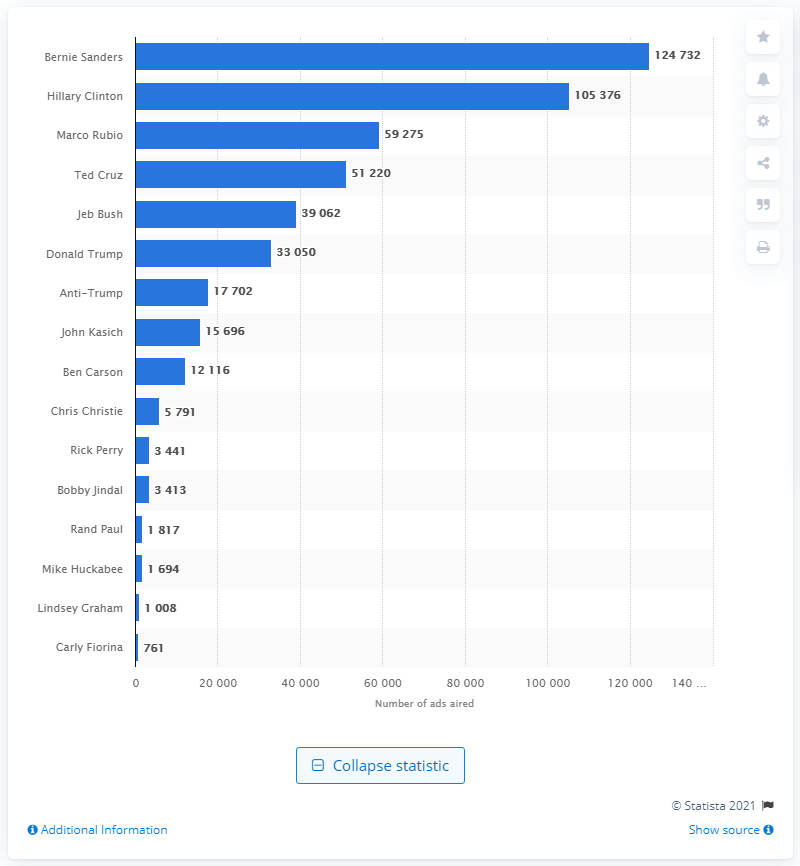Indicate a few pertinent items in this graphic. During the 2016 U.S. presidential election, Bernie Sanders had 124,732 ads aired in his favor. 